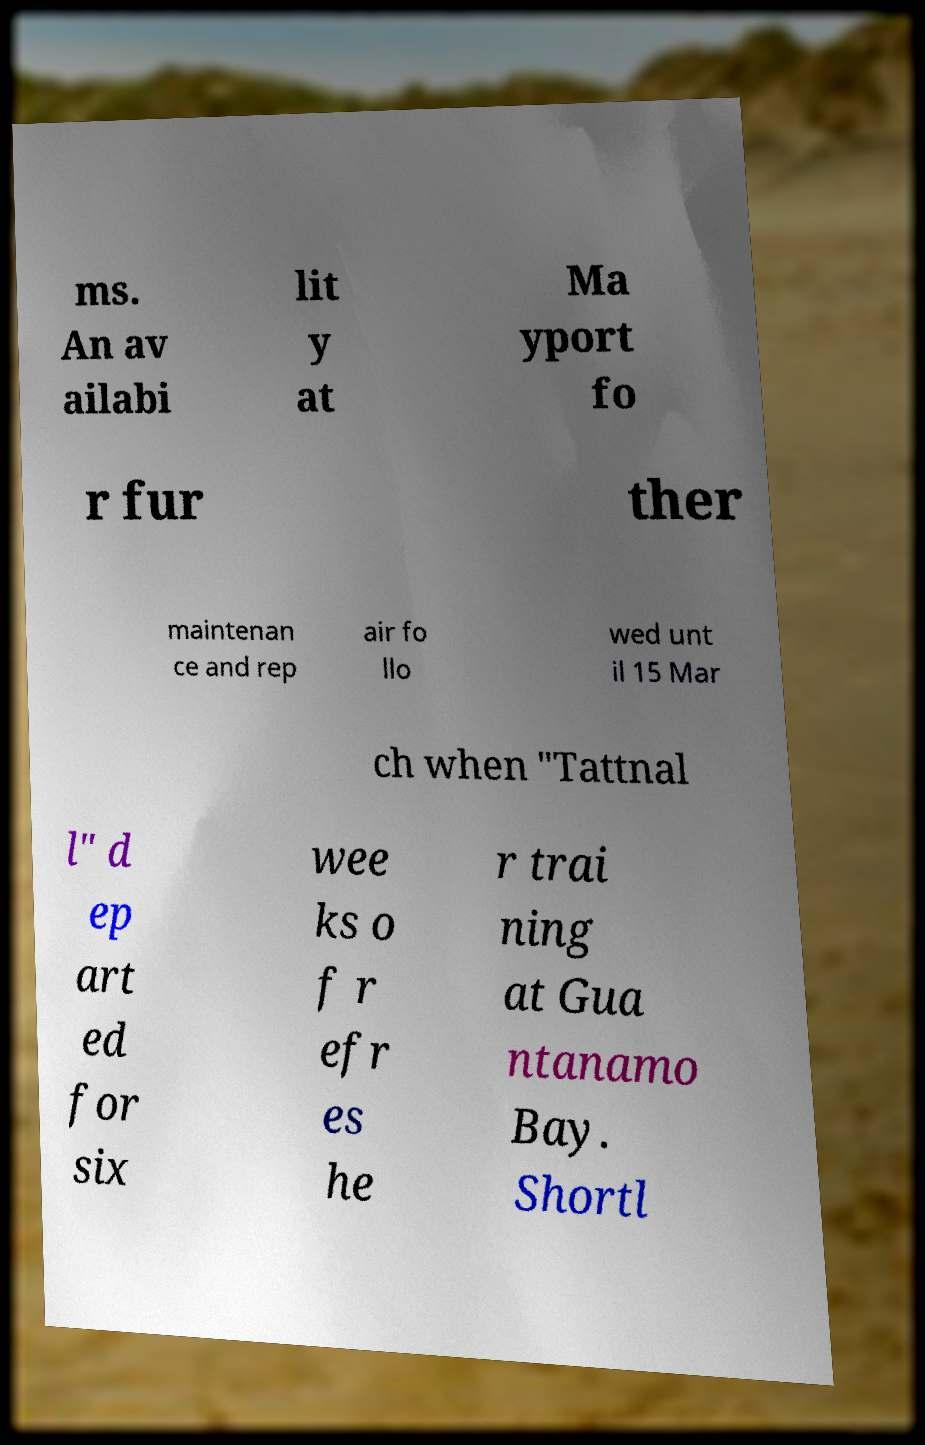For documentation purposes, I need the text within this image transcribed. Could you provide that? ms. An av ailabi lit y at Ma yport fo r fur ther maintenan ce and rep air fo llo wed unt il 15 Mar ch when "Tattnal l" d ep art ed for six wee ks o f r efr es he r trai ning at Gua ntanamo Bay. Shortl 